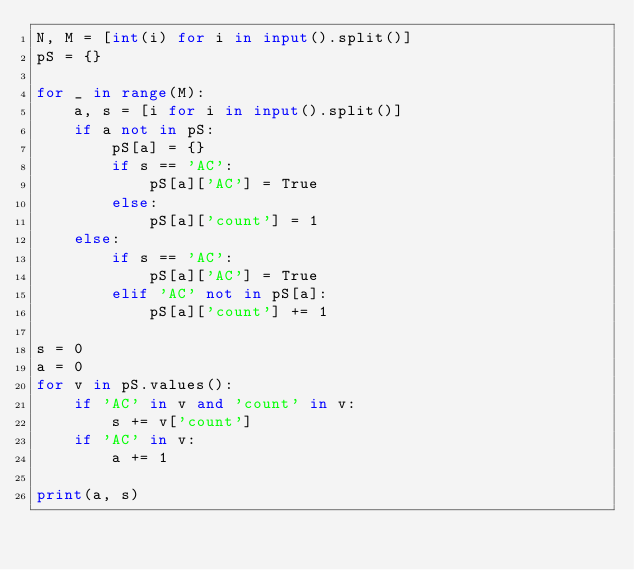Convert code to text. <code><loc_0><loc_0><loc_500><loc_500><_Python_>N, M = [int(i) for i in input().split()]
pS = {}
 
for _ in range(M):
    a, s = [i for i in input().split()]
    if a not in pS:
        pS[a] = {}
        if s == 'AC':
            pS[a]['AC'] = True
        else:
            pS[a]['count'] = 1
    else:
        if s == 'AC':
            pS[a]['AC'] = True
        elif 'AC' not in pS[a]:
            pS[a]['count'] += 1
 
s = 0
a = 0
for v in pS.values():
    if 'AC' in v and 'count' in v:
        s += v['count']
    if 'AC' in v:
        a += 1
    
print(a, s)</code> 